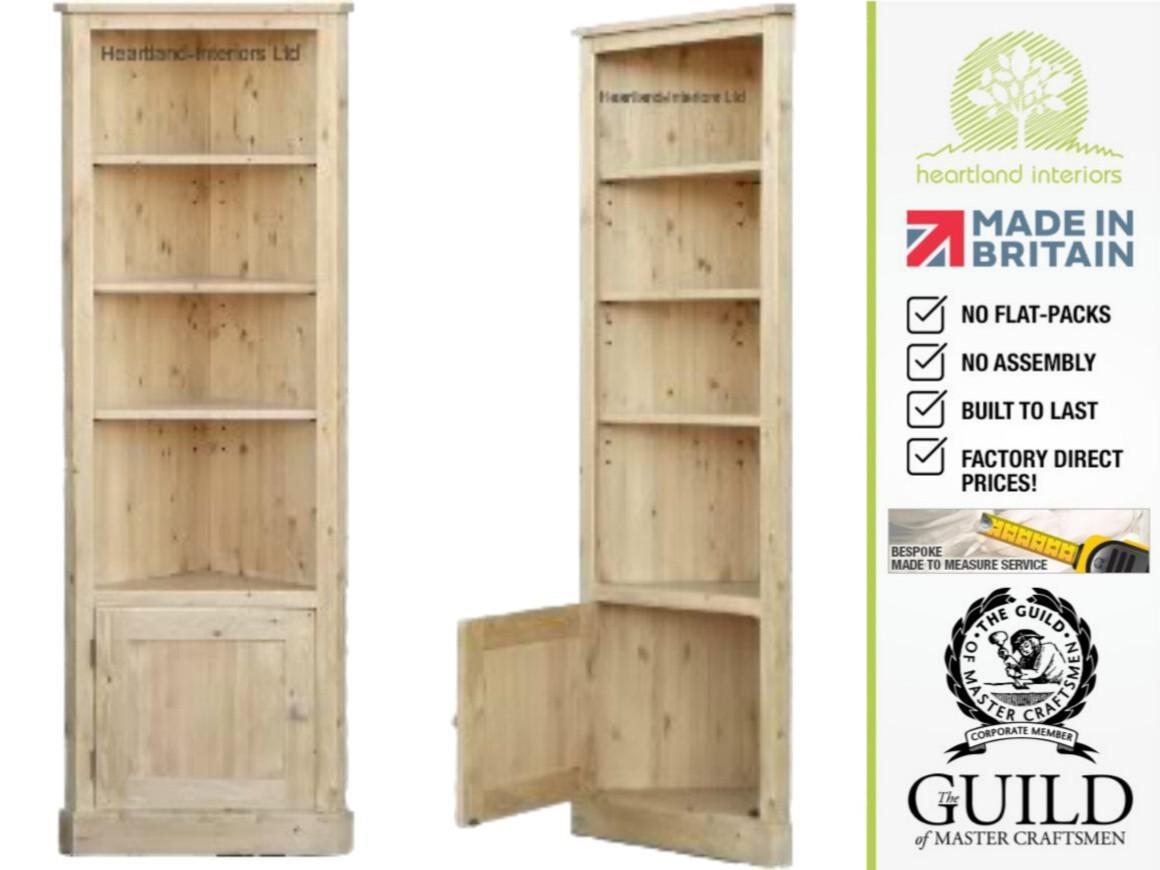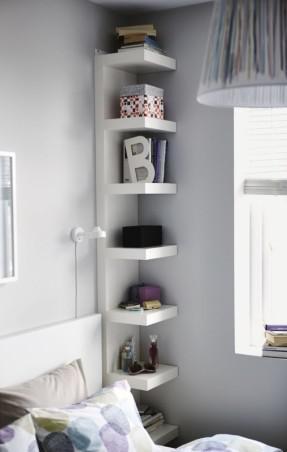The first image is the image on the left, the second image is the image on the right. For the images displayed, is the sentence "An image shows a right-angle white corner cabinet, with a solid back and five shelves." factually correct? Answer yes or no. No. The first image is the image on the left, the second image is the image on the right. Given the left and right images, does the statement "A corner shelf unit is next to a window with long white drapes" hold true? Answer yes or no. No. 